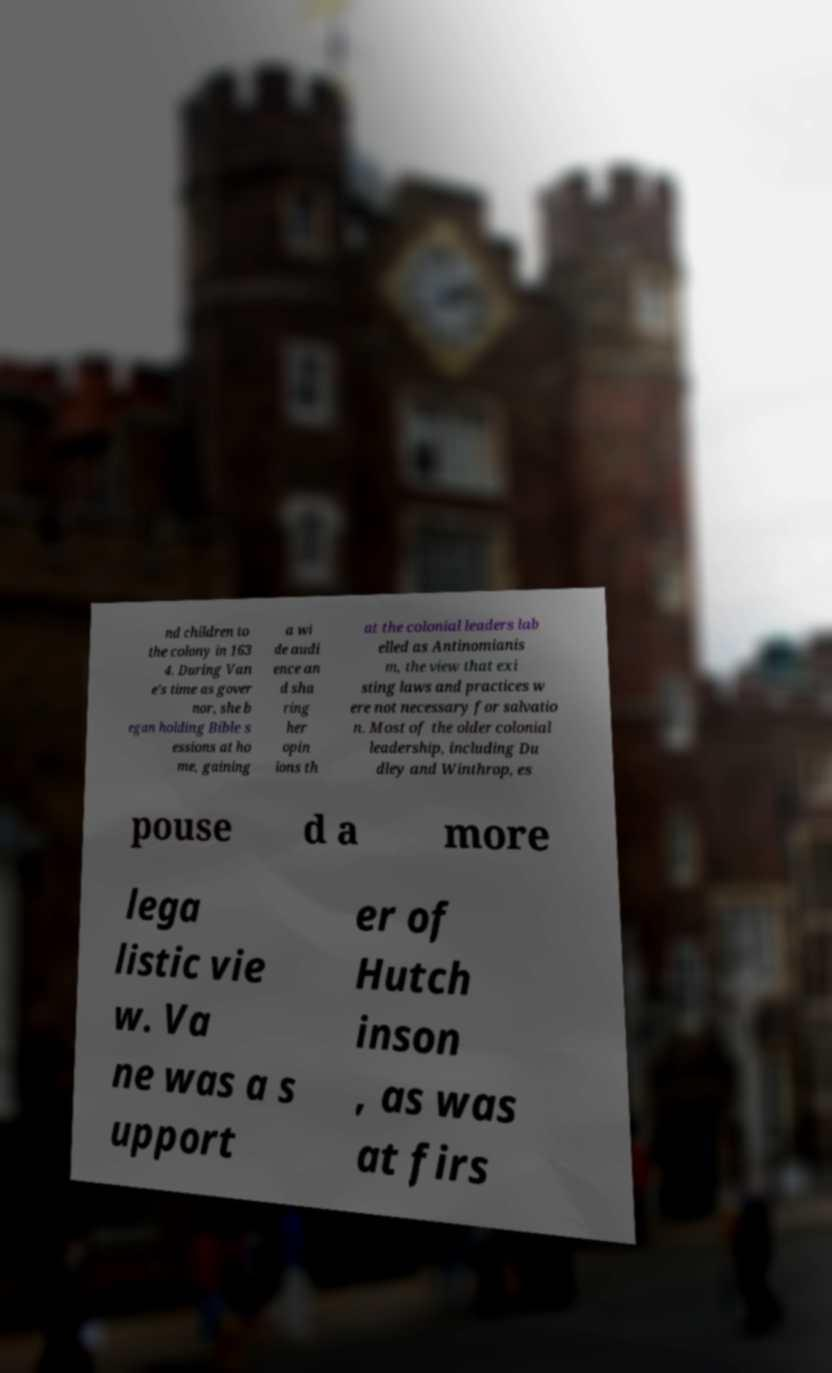What messages or text are displayed in this image? I need them in a readable, typed format. nd children to the colony in 163 4. During Van e's time as gover nor, she b egan holding Bible s essions at ho me, gaining a wi de audi ence an d sha ring her opin ions th at the colonial leaders lab elled as Antinomianis m, the view that exi sting laws and practices w ere not necessary for salvatio n. Most of the older colonial leadership, including Du dley and Winthrop, es pouse d a more lega listic vie w. Va ne was a s upport er of Hutch inson , as was at firs 